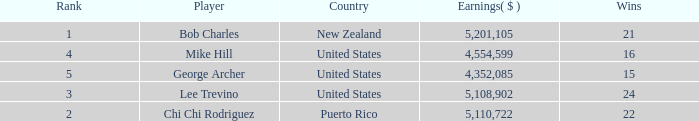What is the lowest level of Earnings($) to have a Wins value of 22 and a Rank lower than 2? None. Help me parse the entirety of this table. {'header': ['Rank', 'Player', 'Country', 'Earnings( $ )', 'Wins'], 'rows': [['1', 'Bob Charles', 'New Zealand', '5,201,105', '21'], ['4', 'Mike Hill', 'United States', '4,554,599', '16'], ['5', 'George Archer', 'United States', '4,352,085', '15'], ['3', 'Lee Trevino', 'United States', '5,108,902', '24'], ['2', 'Chi Chi Rodriguez', 'Puerto Rico', '5,110,722', '22']]} 